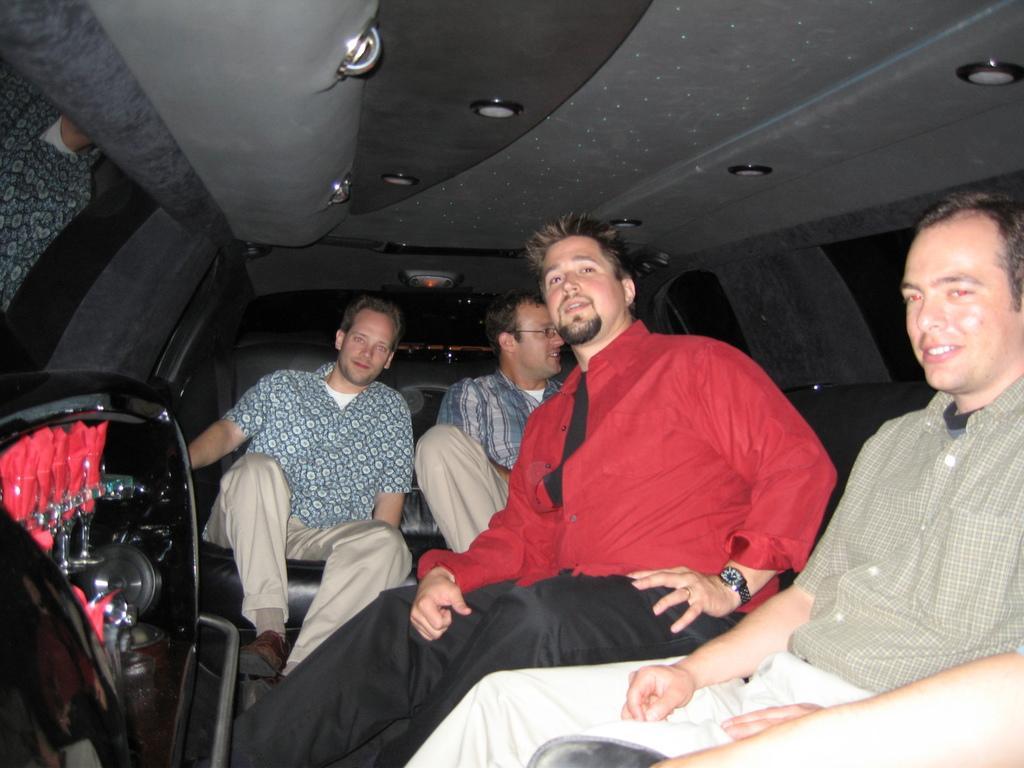Can you describe this image briefly? This image is taken in a vehicle. In the foreground of the image there is an object. In this image there are four people seated. On the top there is ceiling. Seats can be seen. On the right there is a window. 